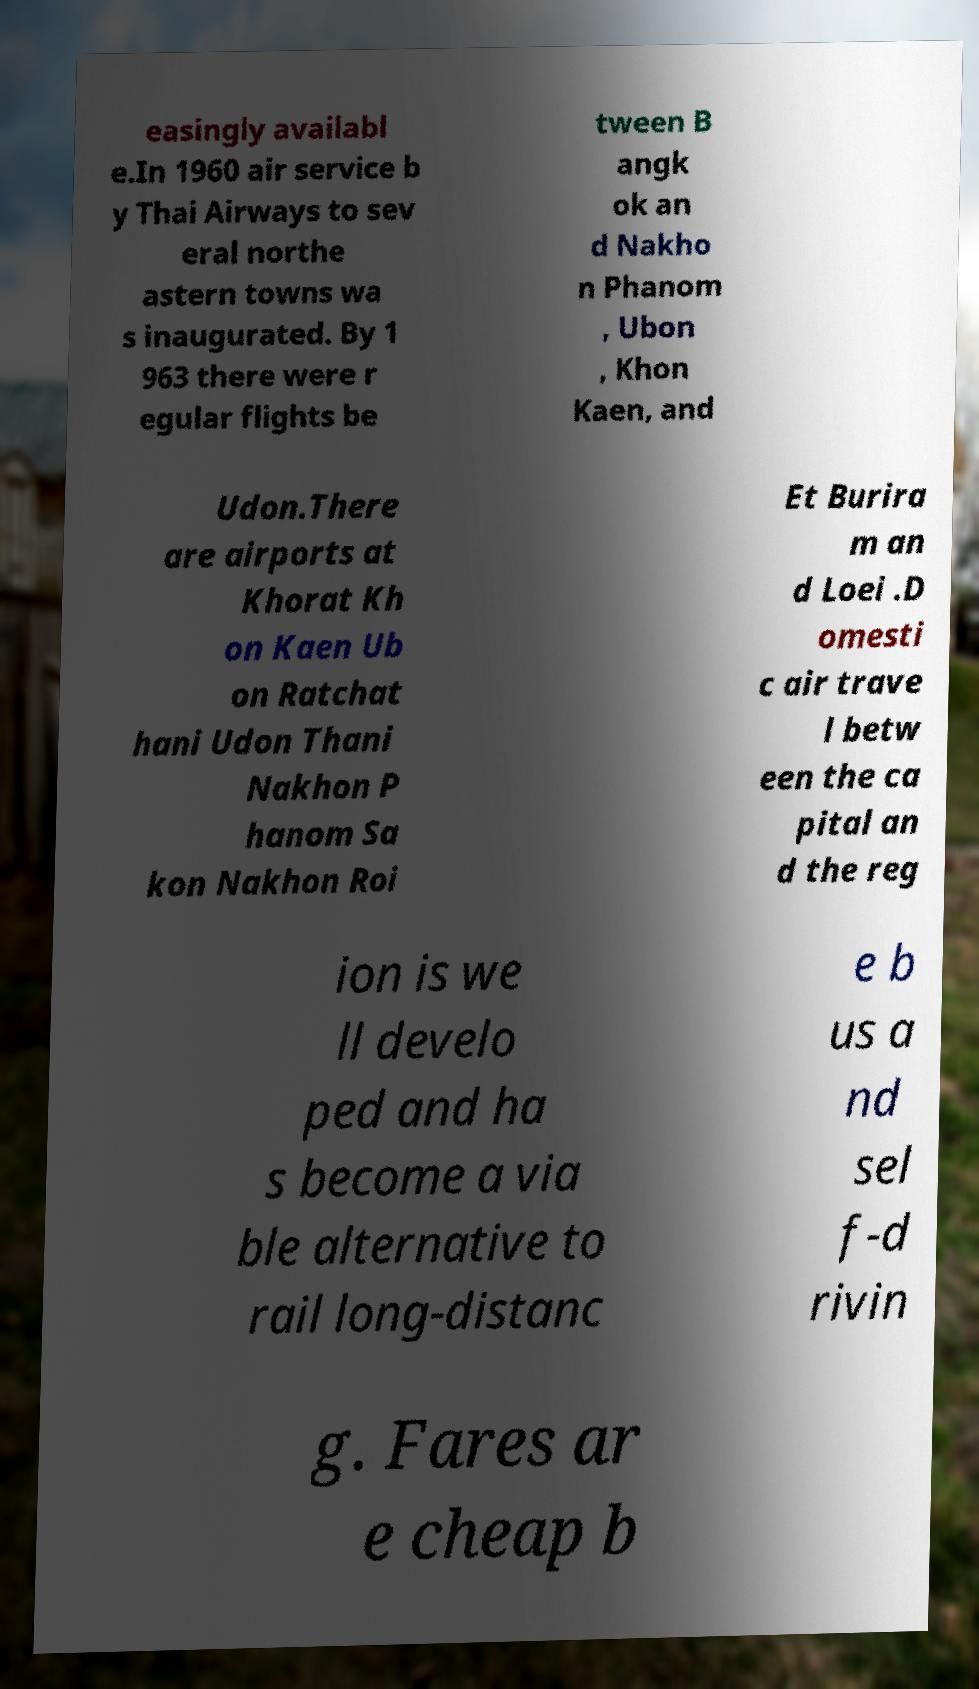Please identify and transcribe the text found in this image. easingly availabl e.In 1960 air service b y Thai Airways to sev eral northe astern towns wa s inaugurated. By 1 963 there were r egular flights be tween B angk ok an d Nakho n Phanom , Ubon , Khon Kaen, and Udon.There are airports at Khorat Kh on Kaen Ub on Ratchat hani Udon Thani Nakhon P hanom Sa kon Nakhon Roi Et Burira m an d Loei .D omesti c air trave l betw een the ca pital an d the reg ion is we ll develo ped and ha s become a via ble alternative to rail long-distanc e b us a nd sel f-d rivin g. Fares ar e cheap b 